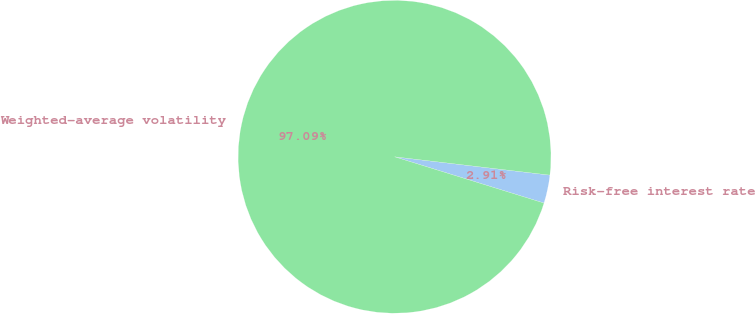Convert chart. <chart><loc_0><loc_0><loc_500><loc_500><pie_chart><fcel>Risk-free interest rate<fcel>Weighted-average volatility<nl><fcel>2.91%<fcel>97.09%<nl></chart> 